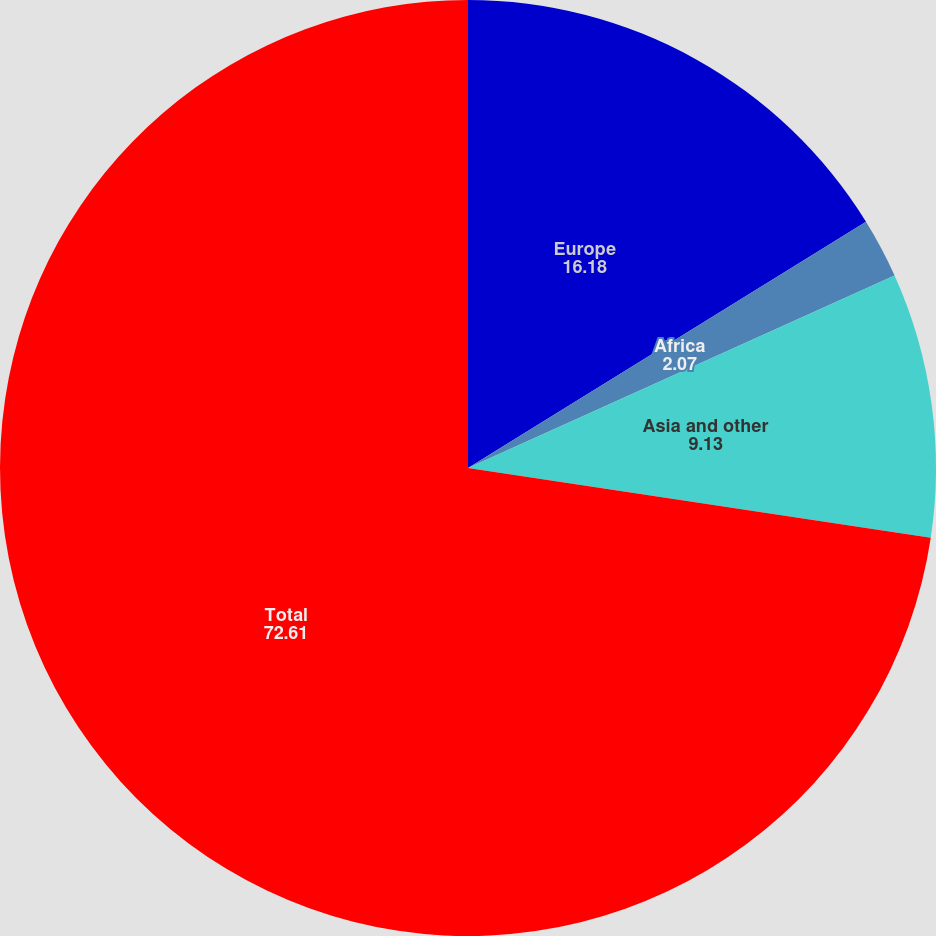Convert chart to OTSL. <chart><loc_0><loc_0><loc_500><loc_500><pie_chart><fcel>Europe<fcel>Africa<fcel>Asia and other<fcel>Total<nl><fcel>16.18%<fcel>2.07%<fcel>9.13%<fcel>72.61%<nl></chart> 